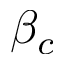Convert formula to latex. <formula><loc_0><loc_0><loc_500><loc_500>\beta _ { c }</formula> 